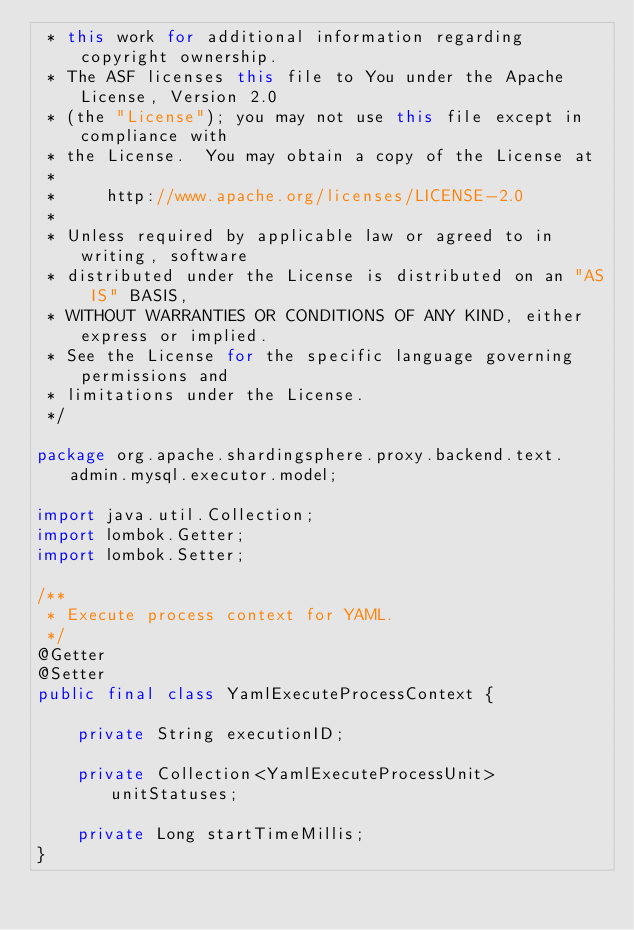Convert code to text. <code><loc_0><loc_0><loc_500><loc_500><_Java_> * this work for additional information regarding copyright ownership.
 * The ASF licenses this file to You under the Apache License, Version 2.0
 * (the "License"); you may not use this file except in compliance with
 * the License.  You may obtain a copy of the License at
 *
 *     http://www.apache.org/licenses/LICENSE-2.0
 *
 * Unless required by applicable law or agreed to in writing, software
 * distributed under the License is distributed on an "AS IS" BASIS,
 * WITHOUT WARRANTIES OR CONDITIONS OF ANY KIND, either express or implied.
 * See the License for the specific language governing permissions and
 * limitations under the License.
 */

package org.apache.shardingsphere.proxy.backend.text.admin.mysql.executor.model;

import java.util.Collection;
import lombok.Getter;
import lombok.Setter;

/**
 * Execute process context for YAML.
 */
@Getter
@Setter
public final class YamlExecuteProcessContext {
    
    private String executionID;
    
    private Collection<YamlExecuteProcessUnit> unitStatuses;
    
    private Long startTimeMillis;
}
</code> 